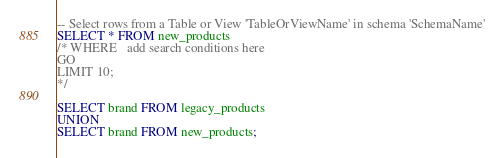<code> <loc_0><loc_0><loc_500><loc_500><_SQL_>-- Select rows from a Table or View 'TableOrViewName' in schema 'SchemaName'
SELECT * FROM new_products
/* WHERE 	 add search conditions here 
GO
LIMIT 10;
*/

SELECT brand FROM legacy_products
UNION 
SELECT brand FROM new_products;
</code> 